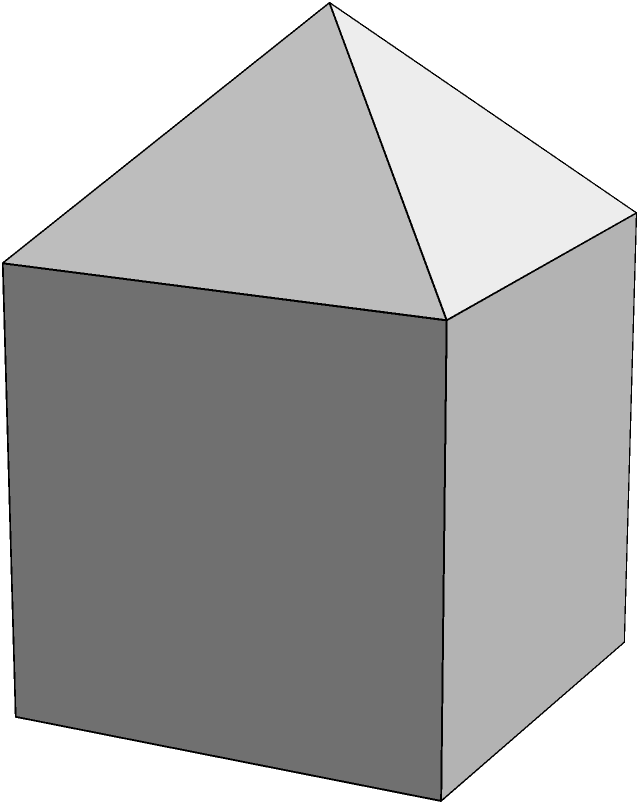In the given complex polyhedron, which is formed by adding a pyramid on top of a cube, how many faces does the entire structure have? To determine the number of faces in this complex polyhedron, let's break it down step-by-step:

1. First, consider the base cube:
   - A cube has 6 faces

2. Now, let's look at the pyramid added on top:
   - The pyramid base replaces one face of the cube
   - The pyramid adds 4 new triangular faces

3. Calculation:
   - Faces from the cube: 6
   - Faces removed by the pyramid base: -1
   - New faces added by the pyramid: +4

4. Total number of faces:
   $6 - 1 + 4 = 9$

Therefore, the complex polyhedron has a total of 9 faces.
Answer: 9 faces 